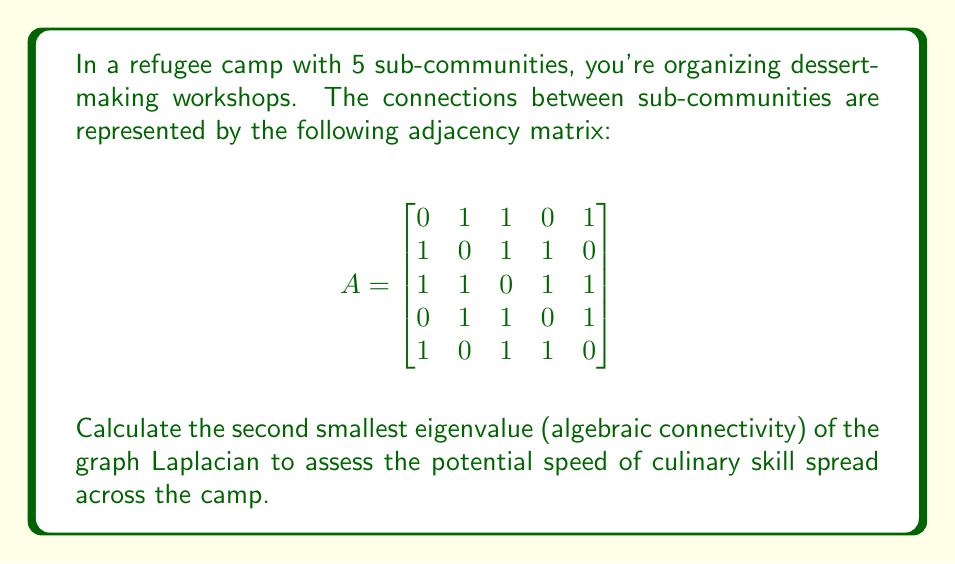Teach me how to tackle this problem. To solve this problem, we'll follow these steps:

1) First, we need to calculate the degree matrix $D$. The degree of each node is the sum of its connections:
   $$D = \begin{bmatrix}
   3 & 0 & 0 & 0 & 0 \\
   0 & 3 & 0 & 0 & 0 \\
   0 & 0 & 4 & 0 & 0 \\
   0 & 0 & 0 & 3 & 0 \\
   0 & 0 & 0 & 0 & 3
   \end{bmatrix}$$

2) Now, we can calculate the graph Laplacian $L = D - A$:
   $$L = \begin{bmatrix}
   3 & -1 & -1 & 0 & -1 \\
   -1 & 3 & -1 & -1 & 0 \\
   -1 & -1 & 4 & -1 & -1 \\
   0 & -1 & -1 & 3 & -1 \\
   -1 & 0 & -1 & -1 & 3
   \end{bmatrix}$$

3) To find the eigenvalues, we need to solve the characteristic equation $\det(L - \lambda I) = 0$. This is a 5th degree polynomial, which is complex to solve by hand.

4) Using a computer algebra system or numerical methods, we can find that the eigenvalues of $L$ are approximately:
   $\lambda_1 \approx 0$
   $\lambda_2 \approx 1.382$
   $\lambda_3 \approx 3$
   $\lambda_4 \approx 4$
   $\lambda_5 \approx 5.618$

5) The second smallest eigenvalue, also known as the algebraic connectivity or Fiedler value, is $\lambda_2 \approx 1.382$.

This value indicates the connectivity of the graph and relates to the speed at which information (in this case, culinary skills) can spread across the network. A higher value suggests faster potential spread.
Answer: $1.382$ 